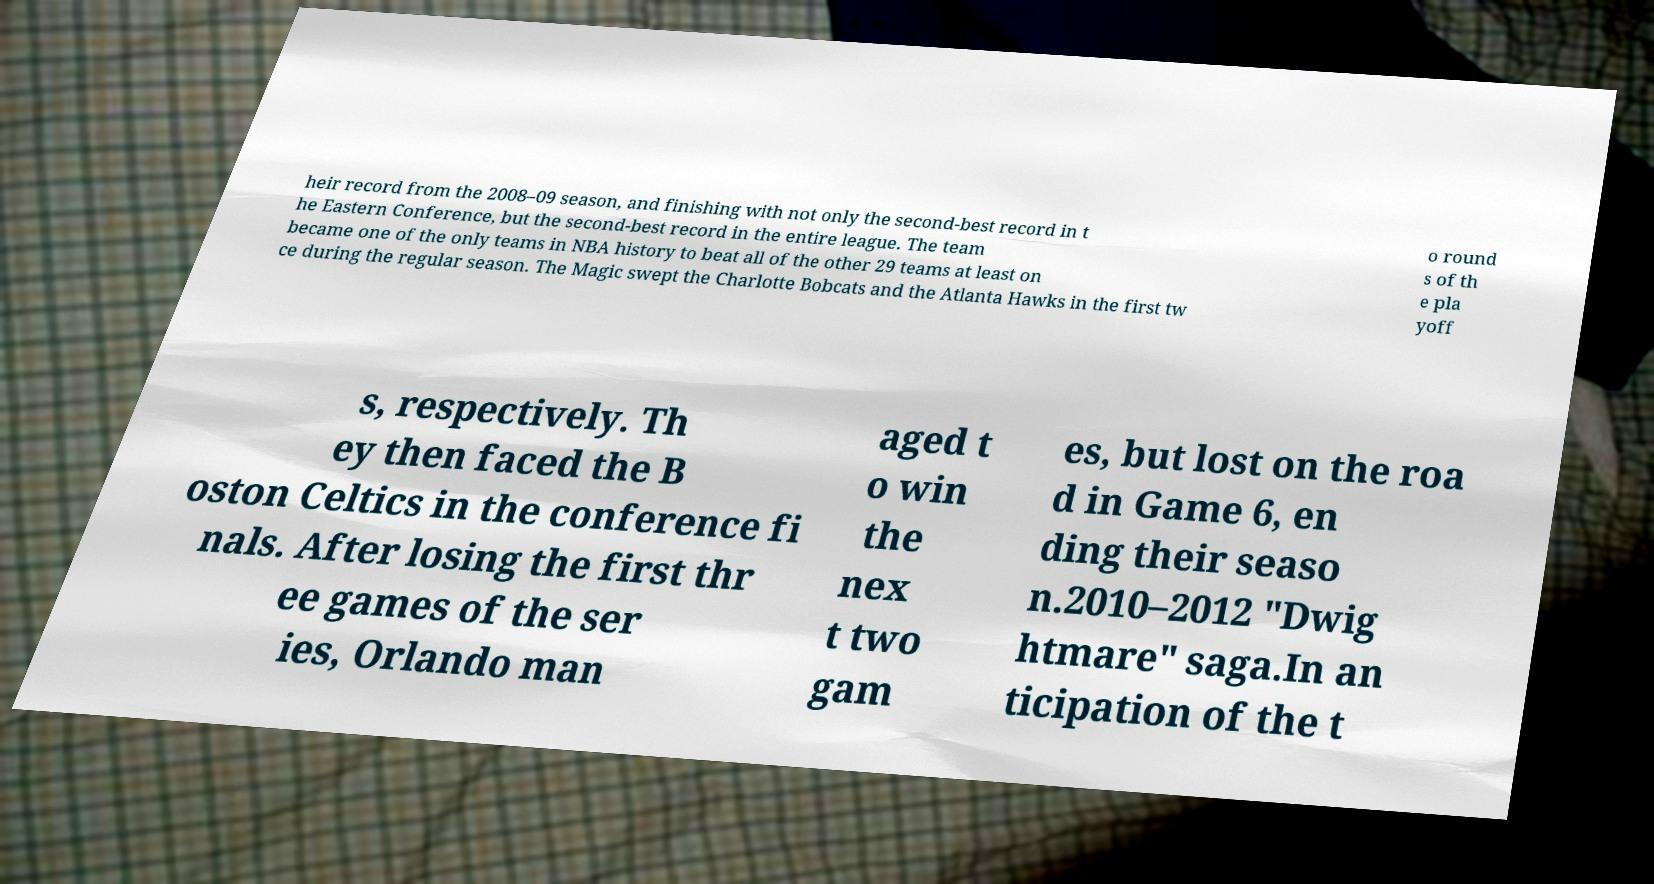Please identify and transcribe the text found in this image. heir record from the 2008–09 season, and finishing with not only the second-best record in t he Eastern Conference, but the second-best record in the entire league. The team became one of the only teams in NBA history to beat all of the other 29 teams at least on ce during the regular season. The Magic swept the Charlotte Bobcats and the Atlanta Hawks in the first tw o round s of th e pla yoff s, respectively. Th ey then faced the B oston Celtics in the conference fi nals. After losing the first thr ee games of the ser ies, Orlando man aged t o win the nex t two gam es, but lost on the roa d in Game 6, en ding their seaso n.2010–2012 "Dwig htmare" saga.In an ticipation of the t 